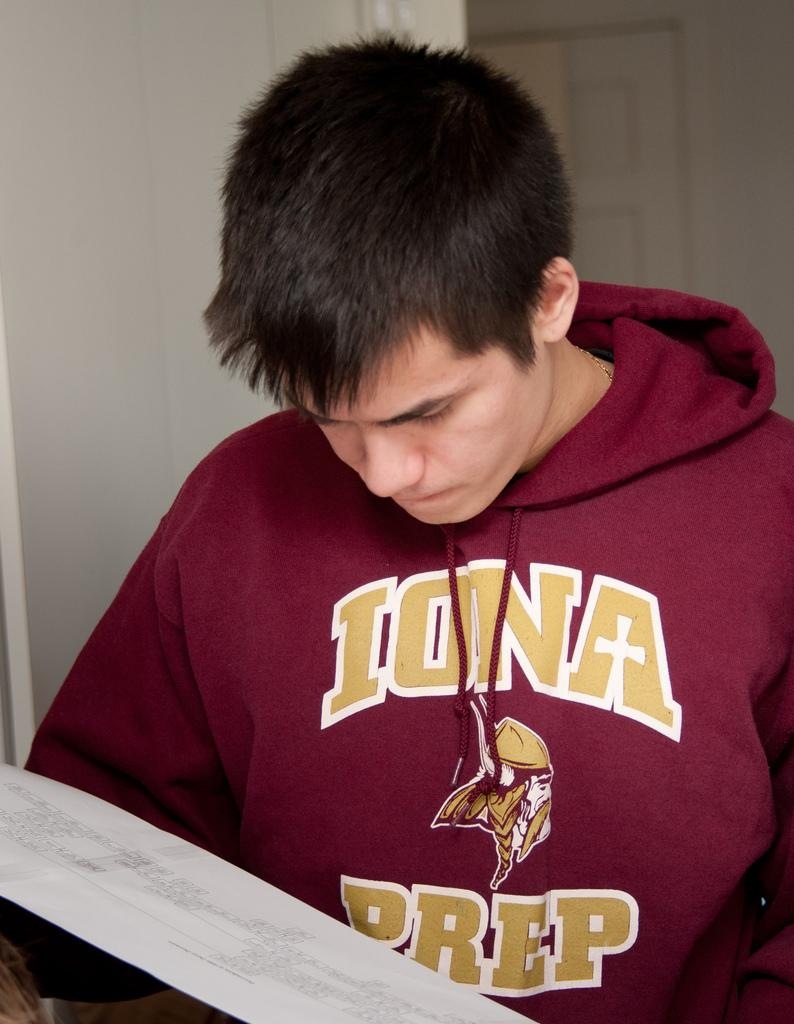<image>
Describe the image concisely. A young man wearing a maroon Iona Prep sweatshirt pullover type jacket. 